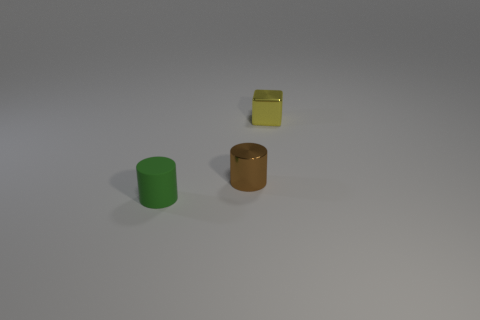Add 3 yellow matte things. How many objects exist? 6 Subtract all blocks. How many objects are left? 2 Add 3 small brown shiny objects. How many small brown shiny objects exist? 4 Subtract 0 blue cubes. How many objects are left? 3 Subtract all cyan blocks. Subtract all small things. How many objects are left? 0 Add 1 green objects. How many green objects are left? 2 